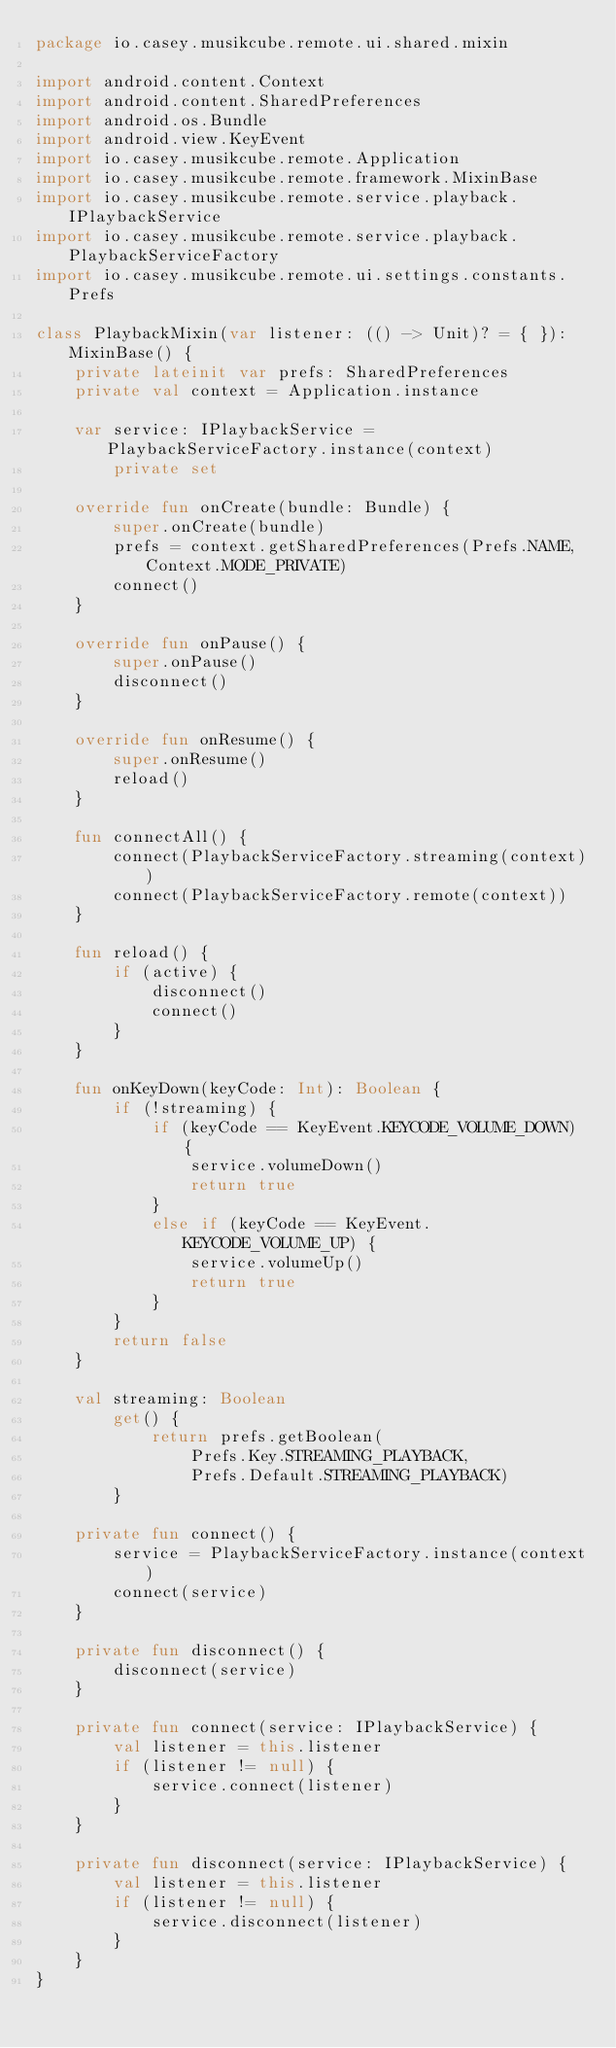Convert code to text. <code><loc_0><loc_0><loc_500><loc_500><_Kotlin_>package io.casey.musikcube.remote.ui.shared.mixin

import android.content.Context
import android.content.SharedPreferences
import android.os.Bundle
import android.view.KeyEvent
import io.casey.musikcube.remote.Application
import io.casey.musikcube.remote.framework.MixinBase
import io.casey.musikcube.remote.service.playback.IPlaybackService
import io.casey.musikcube.remote.service.playback.PlaybackServiceFactory
import io.casey.musikcube.remote.ui.settings.constants.Prefs

class PlaybackMixin(var listener: (() -> Unit)? = { }): MixinBase() {
    private lateinit var prefs: SharedPreferences
    private val context = Application.instance

    var service: IPlaybackService = PlaybackServiceFactory.instance(context)
        private set

    override fun onCreate(bundle: Bundle) {
        super.onCreate(bundle)
        prefs = context.getSharedPreferences(Prefs.NAME, Context.MODE_PRIVATE)
        connect()
    }

    override fun onPause() {
        super.onPause()
        disconnect()
    }

    override fun onResume() {
        super.onResume()
        reload()
    }

    fun connectAll() {
        connect(PlaybackServiceFactory.streaming(context))
        connect(PlaybackServiceFactory.remote(context))
    }

    fun reload() {
        if (active) {
            disconnect()
            connect()
        }
    }

    fun onKeyDown(keyCode: Int): Boolean {
        if (!streaming) {
            if (keyCode == KeyEvent.KEYCODE_VOLUME_DOWN) {
                service.volumeDown()
                return true
            }
            else if (keyCode == KeyEvent.KEYCODE_VOLUME_UP) {
                service.volumeUp()
                return true
            }
        }
        return false
    }

    val streaming: Boolean
        get() {
            return prefs.getBoolean(
                Prefs.Key.STREAMING_PLAYBACK,
                Prefs.Default.STREAMING_PLAYBACK)
        }

    private fun connect() {
        service = PlaybackServiceFactory.instance(context)
        connect(service)
    }

    private fun disconnect() {
        disconnect(service)
    }

    private fun connect(service: IPlaybackService) {
        val listener = this.listener
        if (listener != null) {
            service.connect(listener)
        }
    }

    private fun disconnect(service: IPlaybackService) {
        val listener = this.listener
        if (listener != null) {
            service.disconnect(listener)
        }
    }
}</code> 